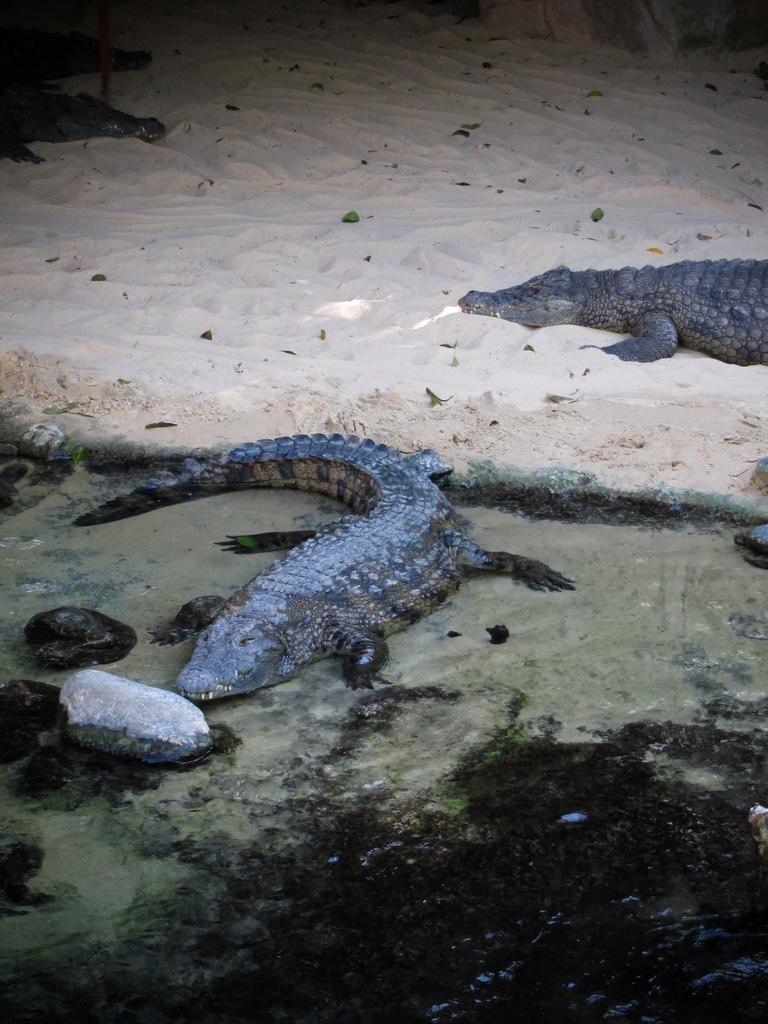Could you give a brief overview of what you see in this image? In this image I can see two crocodiles, they are in brown and gray color. In front I can see few stones, background the sand is in cream color. 